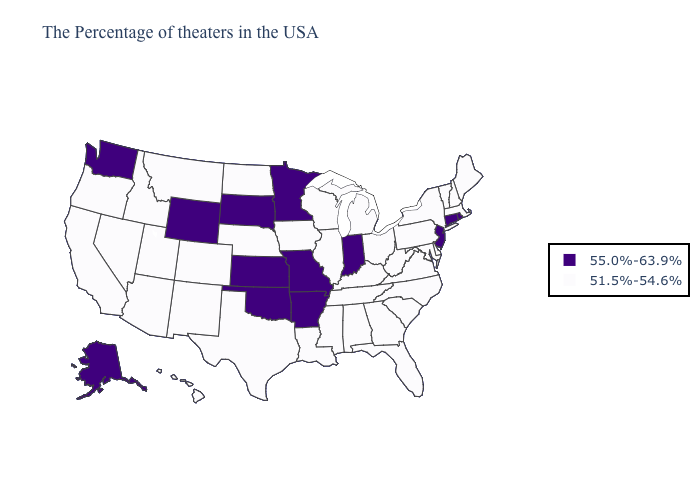What is the highest value in the USA?
Short answer required. 55.0%-63.9%. Does Alaska have the highest value in the West?
Keep it brief. Yes. Name the states that have a value in the range 55.0%-63.9%?
Keep it brief. Rhode Island, Connecticut, New Jersey, Indiana, Missouri, Arkansas, Minnesota, Kansas, Oklahoma, South Dakota, Wyoming, Washington, Alaska. Name the states that have a value in the range 55.0%-63.9%?
Keep it brief. Rhode Island, Connecticut, New Jersey, Indiana, Missouri, Arkansas, Minnesota, Kansas, Oklahoma, South Dakota, Wyoming, Washington, Alaska. What is the highest value in the USA?
Quick response, please. 55.0%-63.9%. Is the legend a continuous bar?
Answer briefly. No. Does the map have missing data?
Quick response, please. No. Does Kentucky have a lower value than Arkansas?
Short answer required. Yes. Is the legend a continuous bar?
Give a very brief answer. No. Name the states that have a value in the range 51.5%-54.6%?
Quick response, please. Maine, Massachusetts, New Hampshire, Vermont, New York, Delaware, Maryland, Pennsylvania, Virginia, North Carolina, South Carolina, West Virginia, Ohio, Florida, Georgia, Michigan, Kentucky, Alabama, Tennessee, Wisconsin, Illinois, Mississippi, Louisiana, Iowa, Nebraska, Texas, North Dakota, Colorado, New Mexico, Utah, Montana, Arizona, Idaho, Nevada, California, Oregon, Hawaii. Does the map have missing data?
Quick response, please. No. Does Colorado have the highest value in the USA?
Keep it brief. No. What is the value of New Jersey?
Quick response, please. 55.0%-63.9%. What is the value of North Carolina?
Be succinct. 51.5%-54.6%. 